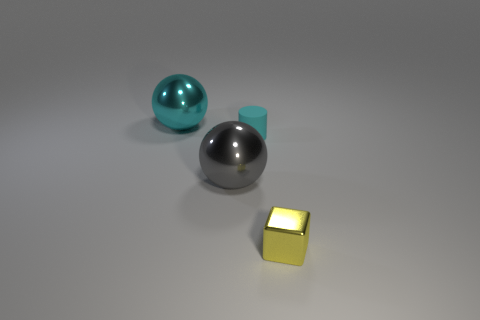Add 2 matte things. How many objects exist? 6 Subtract all cubes. How many objects are left? 3 Add 2 cyan metal spheres. How many cyan metal spheres exist? 3 Subtract 0 red cylinders. How many objects are left? 4 Subtract all red metallic spheres. Subtract all cyan matte objects. How many objects are left? 3 Add 3 large cyan things. How many large cyan things are left? 4 